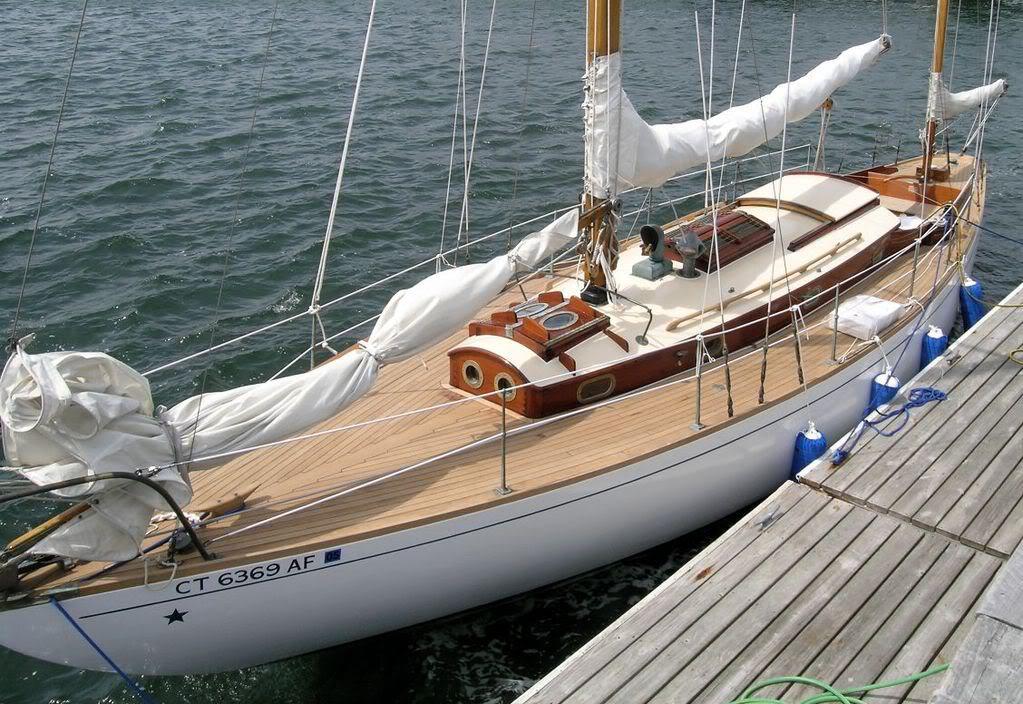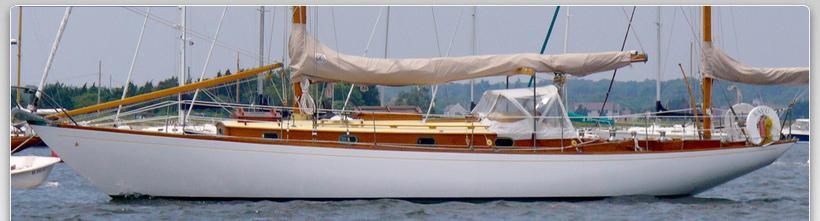The first image is the image on the left, the second image is the image on the right. Assess this claim about the two images: "The sails on both of the sailboats are furled.". Correct or not? Answer yes or no. Yes. 